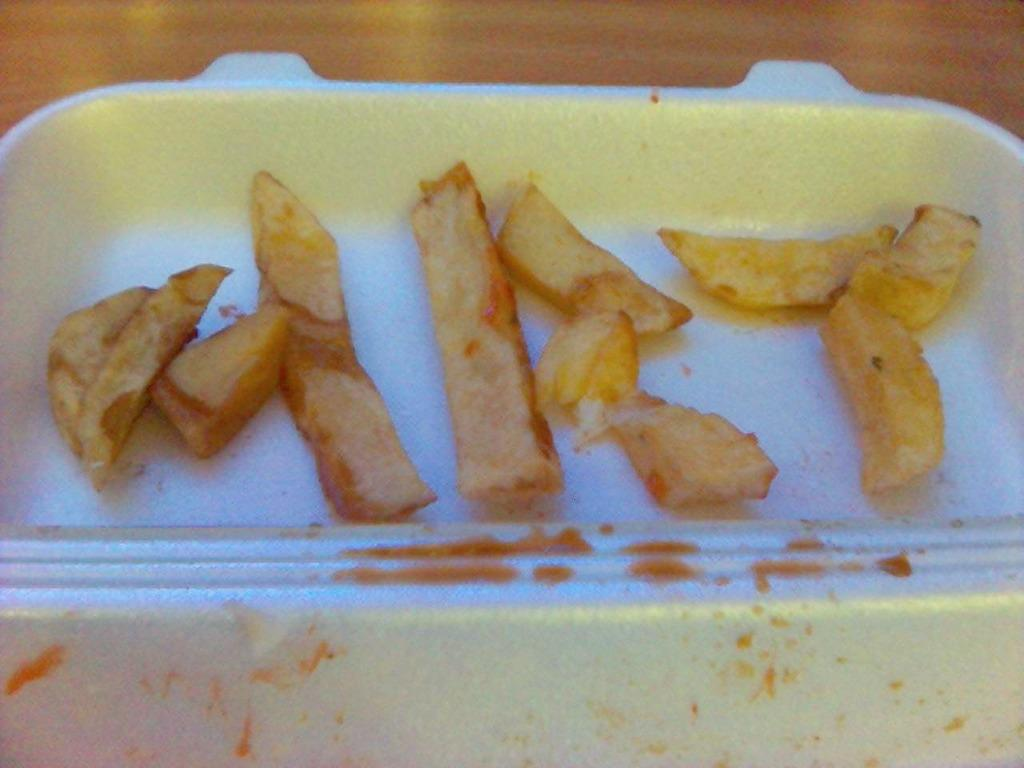What is placed on the plate in the image? There is a plate with food items in the image. Can you describe the food items on the plate? Unfortunately, the specific food items cannot be determined from the provided facts. What might someone be about to do with the plate and food items? Someone might be about to eat the food items on the plate. What type of rake is being used to harvest the quince in the image? There is no rake or quince present in the image; it features a plate with food items. 